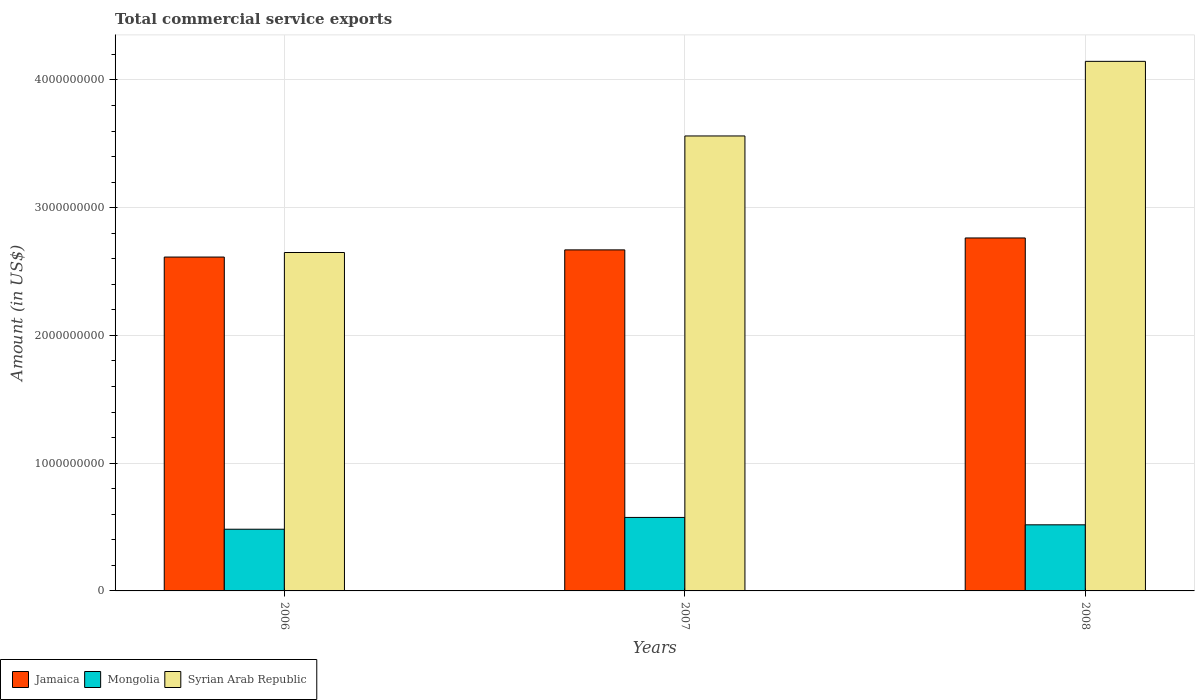How many different coloured bars are there?
Your answer should be very brief. 3. How many groups of bars are there?
Offer a terse response. 3. Are the number of bars per tick equal to the number of legend labels?
Provide a succinct answer. Yes. How many bars are there on the 1st tick from the left?
Keep it short and to the point. 3. How many bars are there on the 2nd tick from the right?
Offer a very short reply. 3. What is the total commercial service exports in Mongolia in 2008?
Keep it short and to the point. 5.17e+08. Across all years, what is the maximum total commercial service exports in Syrian Arab Republic?
Your answer should be very brief. 4.15e+09. Across all years, what is the minimum total commercial service exports in Mongolia?
Offer a very short reply. 4.83e+08. In which year was the total commercial service exports in Mongolia minimum?
Make the answer very short. 2006. What is the total total commercial service exports in Mongolia in the graph?
Your answer should be very brief. 1.58e+09. What is the difference between the total commercial service exports in Mongolia in 2006 and that in 2007?
Offer a terse response. -9.24e+07. What is the difference between the total commercial service exports in Jamaica in 2007 and the total commercial service exports in Syrian Arab Republic in 2006?
Your response must be concise. 2.06e+07. What is the average total commercial service exports in Jamaica per year?
Ensure brevity in your answer.  2.68e+09. In the year 2007, what is the difference between the total commercial service exports in Syrian Arab Republic and total commercial service exports in Mongolia?
Your response must be concise. 2.99e+09. What is the ratio of the total commercial service exports in Syrian Arab Republic in 2007 to that in 2008?
Your response must be concise. 0.86. Is the total commercial service exports in Syrian Arab Republic in 2006 less than that in 2008?
Your response must be concise. Yes. Is the difference between the total commercial service exports in Syrian Arab Republic in 2006 and 2008 greater than the difference between the total commercial service exports in Mongolia in 2006 and 2008?
Provide a short and direct response. No. What is the difference between the highest and the second highest total commercial service exports in Mongolia?
Make the answer very short. 5.79e+07. What is the difference between the highest and the lowest total commercial service exports in Mongolia?
Provide a succinct answer. 9.24e+07. Is the sum of the total commercial service exports in Jamaica in 2006 and 2008 greater than the maximum total commercial service exports in Mongolia across all years?
Provide a succinct answer. Yes. What does the 3rd bar from the left in 2006 represents?
Provide a succinct answer. Syrian Arab Republic. What does the 3rd bar from the right in 2008 represents?
Provide a short and direct response. Jamaica. Is it the case that in every year, the sum of the total commercial service exports in Mongolia and total commercial service exports in Jamaica is greater than the total commercial service exports in Syrian Arab Republic?
Your answer should be very brief. No. How many years are there in the graph?
Keep it short and to the point. 3. Where does the legend appear in the graph?
Offer a terse response. Bottom left. How many legend labels are there?
Give a very brief answer. 3. What is the title of the graph?
Offer a very short reply. Total commercial service exports. Does "Brunei Darussalam" appear as one of the legend labels in the graph?
Your answer should be compact. No. What is the Amount (in US$) of Jamaica in 2006?
Your answer should be compact. 2.61e+09. What is the Amount (in US$) in Mongolia in 2006?
Offer a very short reply. 4.83e+08. What is the Amount (in US$) in Syrian Arab Republic in 2006?
Make the answer very short. 2.65e+09. What is the Amount (in US$) of Jamaica in 2007?
Keep it short and to the point. 2.67e+09. What is the Amount (in US$) of Mongolia in 2007?
Offer a very short reply. 5.75e+08. What is the Amount (in US$) in Syrian Arab Republic in 2007?
Provide a short and direct response. 3.56e+09. What is the Amount (in US$) of Jamaica in 2008?
Offer a very short reply. 2.76e+09. What is the Amount (in US$) of Mongolia in 2008?
Provide a short and direct response. 5.17e+08. What is the Amount (in US$) in Syrian Arab Republic in 2008?
Your response must be concise. 4.15e+09. Across all years, what is the maximum Amount (in US$) in Jamaica?
Make the answer very short. 2.76e+09. Across all years, what is the maximum Amount (in US$) in Mongolia?
Provide a succinct answer. 5.75e+08. Across all years, what is the maximum Amount (in US$) of Syrian Arab Republic?
Offer a very short reply. 4.15e+09. Across all years, what is the minimum Amount (in US$) of Jamaica?
Offer a very short reply. 2.61e+09. Across all years, what is the minimum Amount (in US$) of Mongolia?
Your response must be concise. 4.83e+08. Across all years, what is the minimum Amount (in US$) in Syrian Arab Republic?
Provide a succinct answer. 2.65e+09. What is the total Amount (in US$) in Jamaica in the graph?
Provide a short and direct response. 8.05e+09. What is the total Amount (in US$) in Mongolia in the graph?
Keep it short and to the point. 1.58e+09. What is the total Amount (in US$) in Syrian Arab Republic in the graph?
Your answer should be compact. 1.04e+1. What is the difference between the Amount (in US$) of Jamaica in 2006 and that in 2007?
Give a very brief answer. -5.61e+07. What is the difference between the Amount (in US$) in Mongolia in 2006 and that in 2007?
Your response must be concise. -9.24e+07. What is the difference between the Amount (in US$) in Syrian Arab Republic in 2006 and that in 2007?
Ensure brevity in your answer.  -9.12e+08. What is the difference between the Amount (in US$) of Jamaica in 2006 and that in 2008?
Make the answer very short. -1.49e+08. What is the difference between the Amount (in US$) in Mongolia in 2006 and that in 2008?
Provide a short and direct response. -3.46e+07. What is the difference between the Amount (in US$) of Syrian Arab Republic in 2006 and that in 2008?
Give a very brief answer. -1.50e+09. What is the difference between the Amount (in US$) in Jamaica in 2007 and that in 2008?
Offer a very short reply. -9.33e+07. What is the difference between the Amount (in US$) of Mongolia in 2007 and that in 2008?
Your answer should be compact. 5.79e+07. What is the difference between the Amount (in US$) of Syrian Arab Republic in 2007 and that in 2008?
Make the answer very short. -5.84e+08. What is the difference between the Amount (in US$) in Jamaica in 2006 and the Amount (in US$) in Mongolia in 2007?
Make the answer very short. 2.04e+09. What is the difference between the Amount (in US$) in Jamaica in 2006 and the Amount (in US$) in Syrian Arab Republic in 2007?
Offer a terse response. -9.48e+08. What is the difference between the Amount (in US$) in Mongolia in 2006 and the Amount (in US$) in Syrian Arab Republic in 2007?
Keep it short and to the point. -3.08e+09. What is the difference between the Amount (in US$) of Jamaica in 2006 and the Amount (in US$) of Mongolia in 2008?
Your answer should be compact. 2.10e+09. What is the difference between the Amount (in US$) of Jamaica in 2006 and the Amount (in US$) of Syrian Arab Republic in 2008?
Offer a terse response. -1.53e+09. What is the difference between the Amount (in US$) in Mongolia in 2006 and the Amount (in US$) in Syrian Arab Republic in 2008?
Give a very brief answer. -3.66e+09. What is the difference between the Amount (in US$) of Jamaica in 2007 and the Amount (in US$) of Mongolia in 2008?
Offer a very short reply. 2.15e+09. What is the difference between the Amount (in US$) of Jamaica in 2007 and the Amount (in US$) of Syrian Arab Republic in 2008?
Make the answer very short. -1.48e+09. What is the difference between the Amount (in US$) in Mongolia in 2007 and the Amount (in US$) in Syrian Arab Republic in 2008?
Your answer should be very brief. -3.57e+09. What is the average Amount (in US$) of Jamaica per year?
Ensure brevity in your answer.  2.68e+09. What is the average Amount (in US$) of Mongolia per year?
Provide a short and direct response. 5.25e+08. What is the average Amount (in US$) of Syrian Arab Republic per year?
Offer a terse response. 3.45e+09. In the year 2006, what is the difference between the Amount (in US$) of Jamaica and Amount (in US$) of Mongolia?
Your answer should be compact. 2.13e+09. In the year 2006, what is the difference between the Amount (in US$) in Jamaica and Amount (in US$) in Syrian Arab Republic?
Offer a very short reply. -3.55e+07. In the year 2006, what is the difference between the Amount (in US$) of Mongolia and Amount (in US$) of Syrian Arab Republic?
Provide a short and direct response. -2.17e+09. In the year 2007, what is the difference between the Amount (in US$) in Jamaica and Amount (in US$) in Mongolia?
Your answer should be very brief. 2.09e+09. In the year 2007, what is the difference between the Amount (in US$) of Jamaica and Amount (in US$) of Syrian Arab Republic?
Give a very brief answer. -8.92e+08. In the year 2007, what is the difference between the Amount (in US$) of Mongolia and Amount (in US$) of Syrian Arab Republic?
Keep it short and to the point. -2.99e+09. In the year 2008, what is the difference between the Amount (in US$) of Jamaica and Amount (in US$) of Mongolia?
Your response must be concise. 2.25e+09. In the year 2008, what is the difference between the Amount (in US$) of Jamaica and Amount (in US$) of Syrian Arab Republic?
Your response must be concise. -1.38e+09. In the year 2008, what is the difference between the Amount (in US$) of Mongolia and Amount (in US$) of Syrian Arab Republic?
Offer a terse response. -3.63e+09. What is the ratio of the Amount (in US$) of Mongolia in 2006 to that in 2007?
Provide a short and direct response. 0.84. What is the ratio of the Amount (in US$) of Syrian Arab Republic in 2006 to that in 2007?
Ensure brevity in your answer.  0.74. What is the ratio of the Amount (in US$) of Jamaica in 2006 to that in 2008?
Your answer should be compact. 0.95. What is the ratio of the Amount (in US$) of Mongolia in 2006 to that in 2008?
Offer a terse response. 0.93. What is the ratio of the Amount (in US$) in Syrian Arab Republic in 2006 to that in 2008?
Your answer should be very brief. 0.64. What is the ratio of the Amount (in US$) of Jamaica in 2007 to that in 2008?
Keep it short and to the point. 0.97. What is the ratio of the Amount (in US$) in Mongolia in 2007 to that in 2008?
Make the answer very short. 1.11. What is the ratio of the Amount (in US$) in Syrian Arab Republic in 2007 to that in 2008?
Ensure brevity in your answer.  0.86. What is the difference between the highest and the second highest Amount (in US$) in Jamaica?
Keep it short and to the point. 9.33e+07. What is the difference between the highest and the second highest Amount (in US$) of Mongolia?
Ensure brevity in your answer.  5.79e+07. What is the difference between the highest and the second highest Amount (in US$) of Syrian Arab Republic?
Your answer should be compact. 5.84e+08. What is the difference between the highest and the lowest Amount (in US$) in Jamaica?
Give a very brief answer. 1.49e+08. What is the difference between the highest and the lowest Amount (in US$) of Mongolia?
Provide a succinct answer. 9.24e+07. What is the difference between the highest and the lowest Amount (in US$) of Syrian Arab Republic?
Provide a succinct answer. 1.50e+09. 